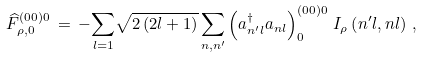Convert formula to latex. <formula><loc_0><loc_0><loc_500><loc_500>\widehat { F } ^ { ( 0 0 ) 0 } _ { \rho , 0 } \, = \, - { \sum _ { l = 1 } } \sqrt { 2 \left ( 2 l + 1 \right ) } \, { \sum _ { n , n ^ { \prime } } } \left ( { a } ^ { \dag } _ { n ^ { \prime } l } { a } _ { n l } \right ) ^ { ( 0 0 ) 0 } _ { 0 } \, I _ { \rho } \left ( n ^ { \prime } l , n l \right ) \, ,</formula> 